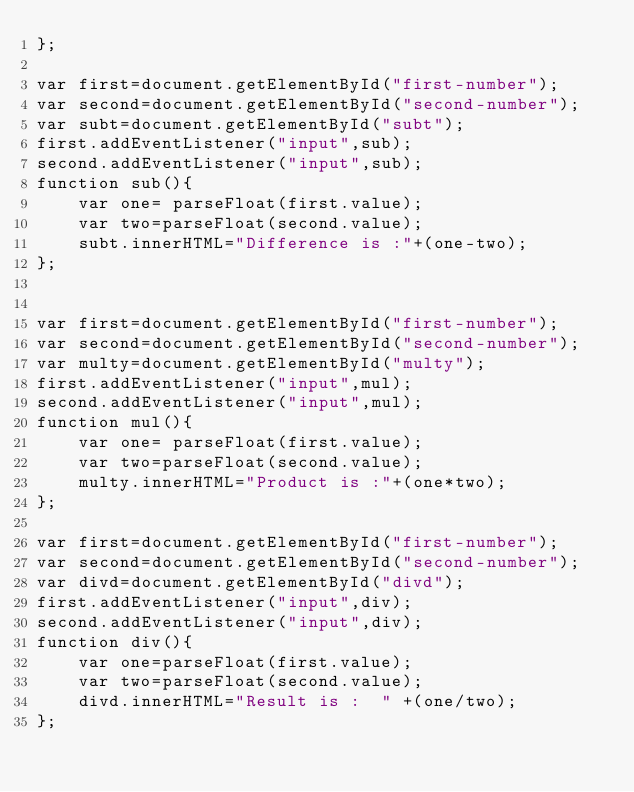<code> <loc_0><loc_0><loc_500><loc_500><_JavaScript_>};

var first=document.getElementById("first-number");
var second=document.getElementById("second-number");
var subt=document.getElementById("subt");
first.addEventListener("input",sub);
second.addEventListener("input",sub);
function sub(){
    var one= parseFloat(first.value);  
    var two=parseFloat(second.value);
    subt.innerHTML="Difference is :"+(one-two);
};


var first=document.getElementById("first-number");
var second=document.getElementById("second-number");
var multy=document.getElementById("multy");
first.addEventListener("input",mul);
second.addEventListener("input",mul);
function mul(){
    var one= parseFloat(first.value);  
    var two=parseFloat(second.value);
    multy.innerHTML="Product is :"+(one*two);
};

var first=document.getElementById("first-number");
var second=document.getElementById("second-number");
var divd=document.getElementById("divd");
first.addEventListener("input",div);
second.addEventListener("input",div);
function div(){
    var one=parseFloat(first.value);
    var two=parseFloat(second.value);
    divd.innerHTML="Result is :  " +(one/two);
};</code> 